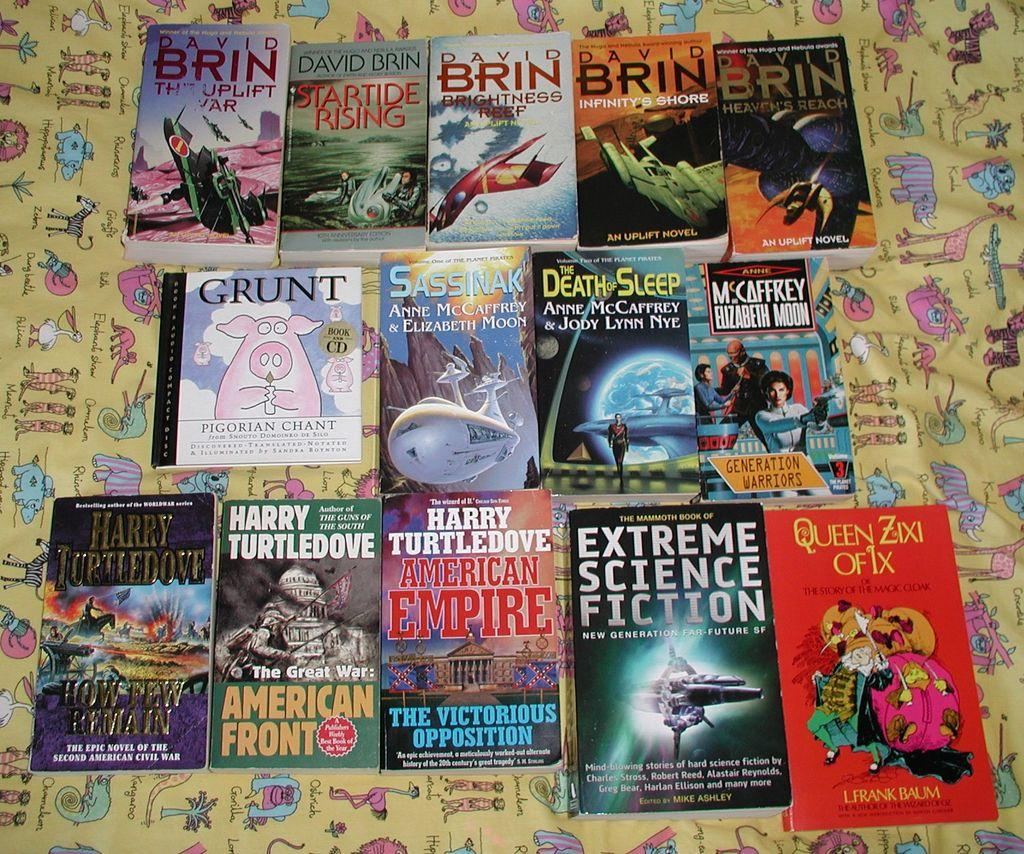<image>
Write a terse but informative summary of the picture. An assortment of paperback books includes titles such as Extreme Science Fiction, Infinity's Shore and How Few Remain. 